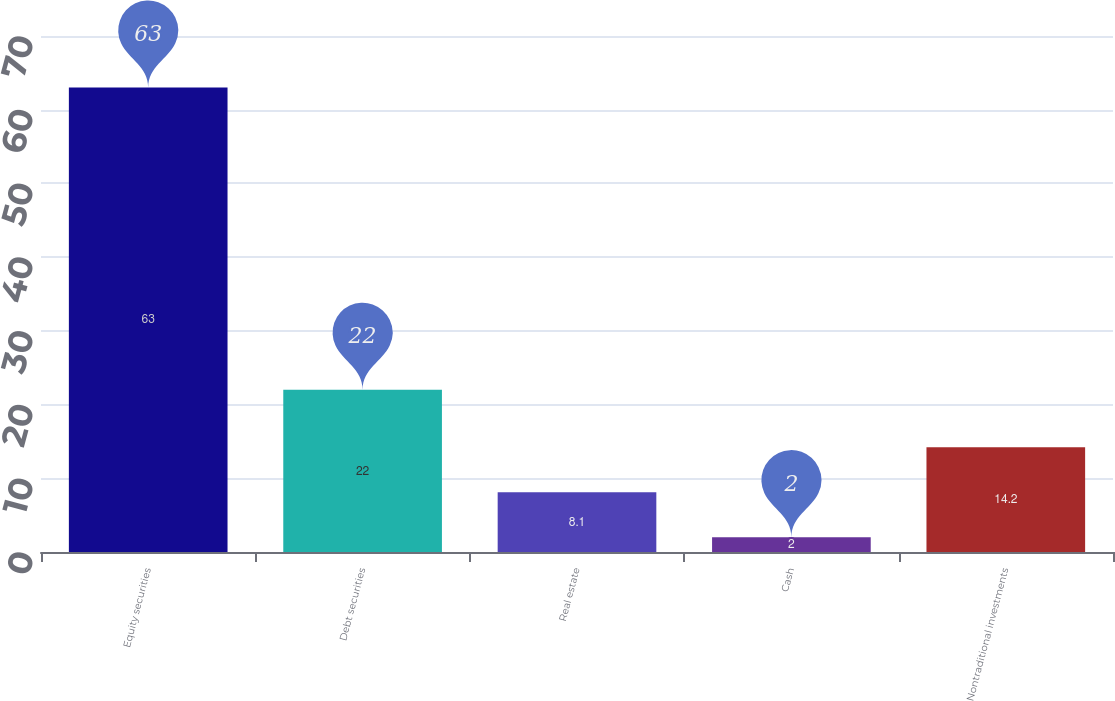<chart> <loc_0><loc_0><loc_500><loc_500><bar_chart><fcel>Equity securities<fcel>Debt securities<fcel>Real estate<fcel>Cash<fcel>Nontraditional investments<nl><fcel>63<fcel>22<fcel>8.1<fcel>2<fcel>14.2<nl></chart> 